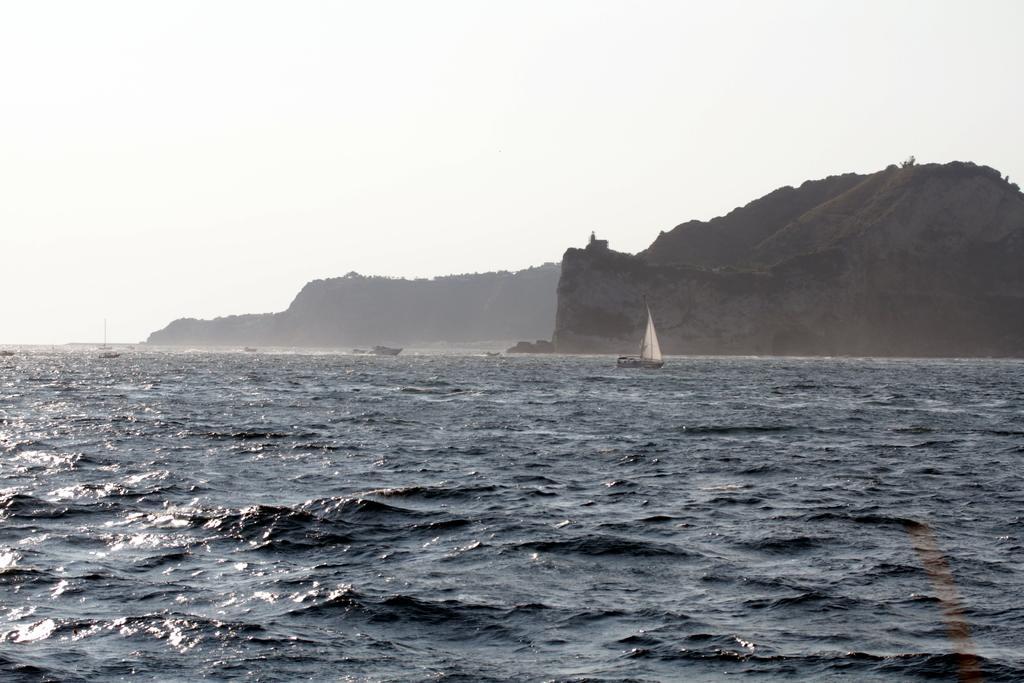How would you summarize this image in a sentence or two? This image consists of an ocean. In which we can see the boats. On the right, it looks like a mountain. At the top, there is sky. 